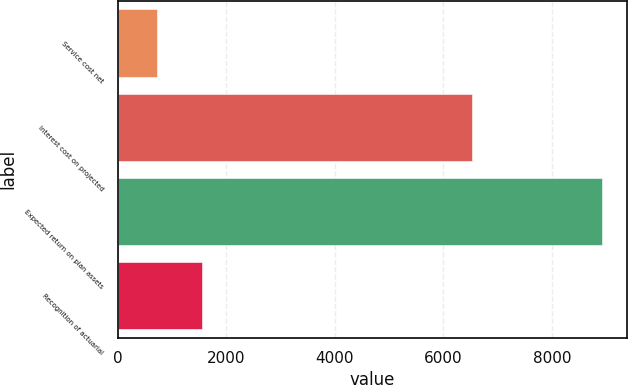Convert chart. <chart><loc_0><loc_0><loc_500><loc_500><bar_chart><fcel>Service cost net<fcel>Interest cost on projected<fcel>Expected return on plan assets<fcel>Recognition of actuarial<nl><fcel>730<fcel>6535<fcel>8931<fcel>1550.1<nl></chart> 